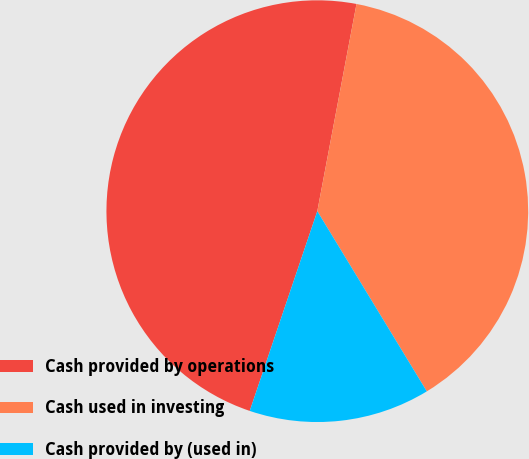Convert chart to OTSL. <chart><loc_0><loc_0><loc_500><loc_500><pie_chart><fcel>Cash provided by operations<fcel>Cash used in investing<fcel>Cash provided by (used in)<nl><fcel>47.78%<fcel>38.33%<fcel>13.88%<nl></chart> 